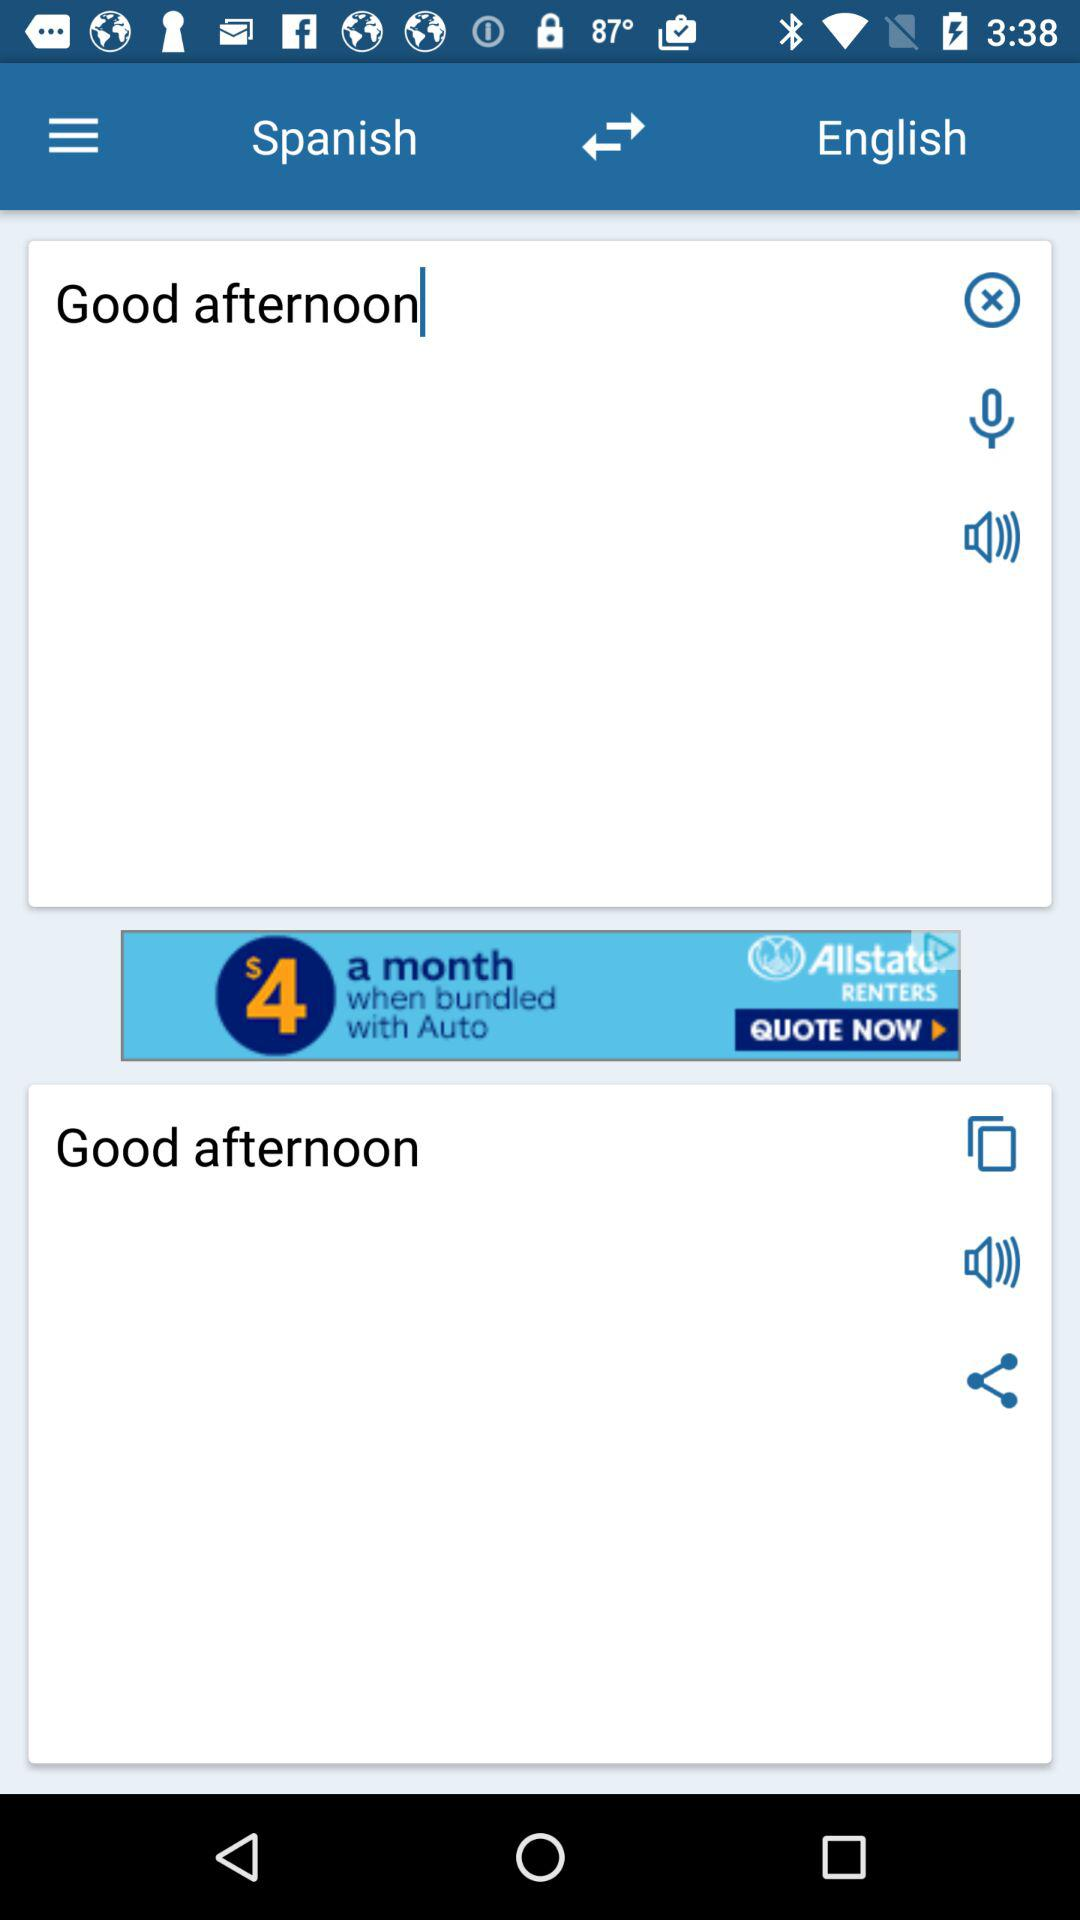What is the text entered for translation? The text entered for translation is "Good afternoon". 